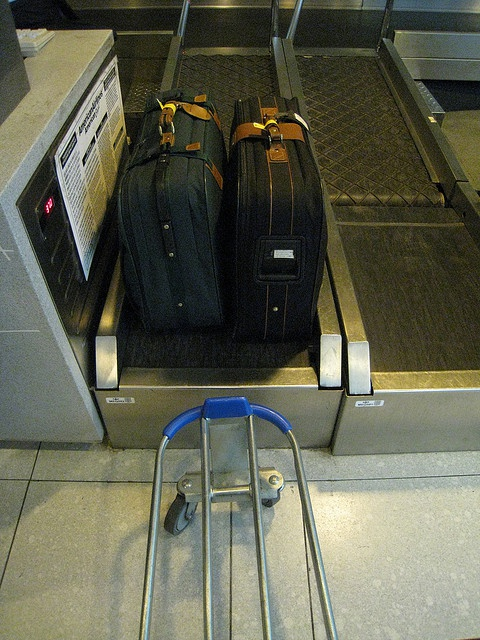Describe the objects in this image and their specific colors. I can see suitcase in black, olive, and darkgreen tones, suitcase in black, olive, and maroon tones, and keyboard in black, darkgray, and gray tones in this image. 